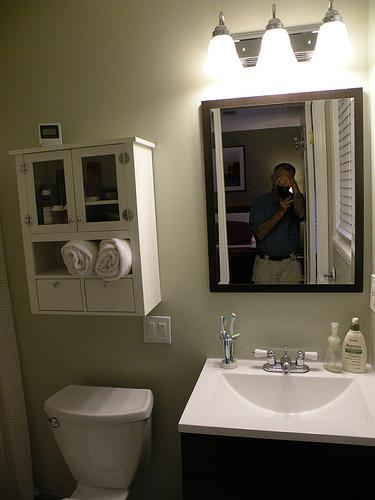Question: what gender is the person in the photo?
Choices:
A. Female.
B. Male.
C. Transgender.
D. Transvestite.
Answer with the letter. Answer: B Question: how many overhead lights are there?
Choices:
A. Three.
B. One.
C. Two.
D. Four.
Answer with the letter. Answer: A Question: where are the towels located?
Choices:
A. On the towel rack.
B. On the floor.
C. In the closet.
D. In the cabinet above the toilet.
Answer with the letter. Answer: D Question: where is the light switch?
Choices:
A. Under the cabinet on the wall.
B. On the door.
C. On the floor.
D. Over the window.
Answer with the letter. Answer: A 